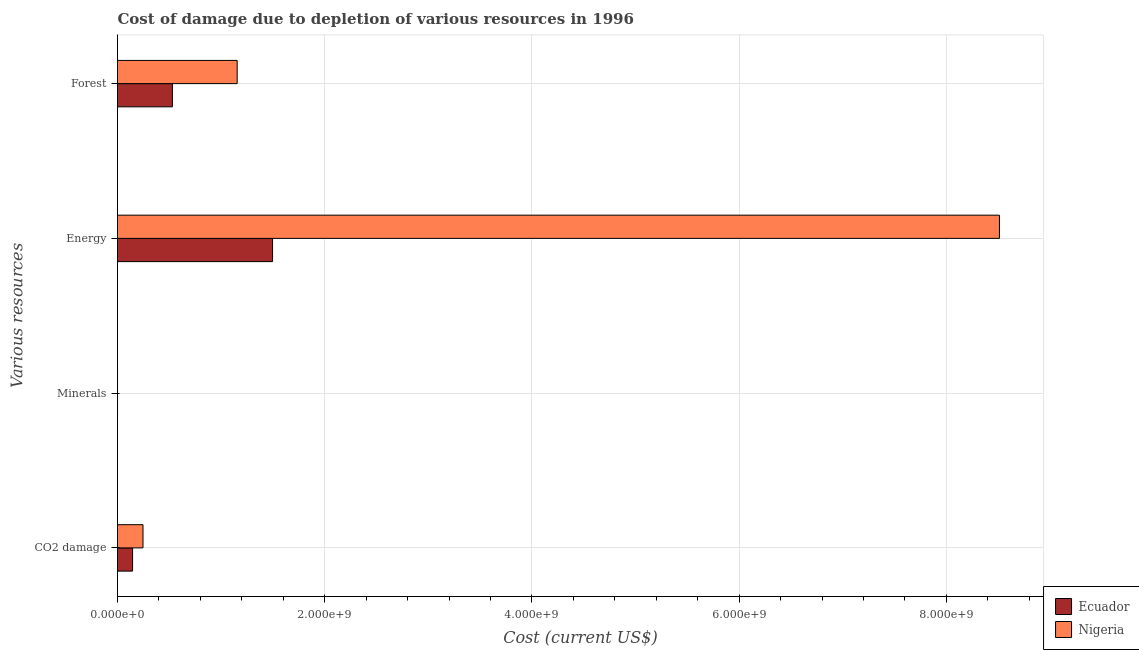Are the number of bars per tick equal to the number of legend labels?
Ensure brevity in your answer.  Yes. Are the number of bars on each tick of the Y-axis equal?
Offer a terse response. Yes. How many bars are there on the 1st tick from the top?
Provide a short and direct response. 2. How many bars are there on the 2nd tick from the bottom?
Offer a very short reply. 2. What is the label of the 1st group of bars from the top?
Offer a very short reply. Forest. What is the cost of damage due to depletion of minerals in Nigeria?
Keep it short and to the point. 1.73e+05. Across all countries, what is the maximum cost of damage due to depletion of minerals?
Ensure brevity in your answer.  1.73e+05. Across all countries, what is the minimum cost of damage due to depletion of energy?
Your response must be concise. 1.50e+09. In which country was the cost of damage due to depletion of coal maximum?
Your answer should be compact. Nigeria. In which country was the cost of damage due to depletion of coal minimum?
Your answer should be compact. Ecuador. What is the total cost of damage due to depletion of energy in the graph?
Your answer should be very brief. 1.00e+1. What is the difference between the cost of damage due to depletion of energy in Nigeria and that in Ecuador?
Make the answer very short. 7.02e+09. What is the difference between the cost of damage due to depletion of minerals in Ecuador and the cost of damage due to depletion of forests in Nigeria?
Provide a succinct answer. -1.15e+09. What is the average cost of damage due to depletion of forests per country?
Your answer should be very brief. 8.42e+08. What is the difference between the cost of damage due to depletion of minerals and cost of damage due to depletion of energy in Ecuador?
Provide a short and direct response. -1.50e+09. What is the ratio of the cost of damage due to depletion of energy in Nigeria to that in Ecuador?
Offer a very short reply. 5.69. Is the cost of damage due to depletion of forests in Nigeria less than that in Ecuador?
Offer a very short reply. No. Is the difference between the cost of damage due to depletion of energy in Nigeria and Ecuador greater than the difference between the cost of damage due to depletion of minerals in Nigeria and Ecuador?
Offer a terse response. Yes. What is the difference between the highest and the second highest cost of damage due to depletion of forests?
Your answer should be compact. 6.25e+08. What is the difference between the highest and the lowest cost of damage due to depletion of forests?
Give a very brief answer. 6.25e+08. In how many countries, is the cost of damage due to depletion of coal greater than the average cost of damage due to depletion of coal taken over all countries?
Offer a terse response. 1. What does the 1st bar from the top in Minerals represents?
Provide a succinct answer. Nigeria. What does the 1st bar from the bottom in Forest represents?
Your response must be concise. Ecuador. How many bars are there?
Offer a very short reply. 8. Does the graph contain any zero values?
Your answer should be compact. No. Does the graph contain grids?
Ensure brevity in your answer.  Yes. How many legend labels are there?
Give a very brief answer. 2. How are the legend labels stacked?
Provide a short and direct response. Vertical. What is the title of the graph?
Offer a very short reply. Cost of damage due to depletion of various resources in 1996 . What is the label or title of the X-axis?
Your response must be concise. Cost (current US$). What is the label or title of the Y-axis?
Offer a very short reply. Various resources. What is the Cost (current US$) of Ecuador in CO2 damage?
Offer a terse response. 1.45e+08. What is the Cost (current US$) in Nigeria in CO2 damage?
Provide a short and direct response. 2.46e+08. What is the Cost (current US$) of Ecuador in Minerals?
Give a very brief answer. 5.43e+04. What is the Cost (current US$) in Nigeria in Minerals?
Your answer should be very brief. 1.73e+05. What is the Cost (current US$) in Ecuador in Energy?
Your response must be concise. 1.50e+09. What is the Cost (current US$) in Nigeria in Energy?
Give a very brief answer. 8.51e+09. What is the Cost (current US$) in Ecuador in Forest?
Provide a succinct answer. 5.30e+08. What is the Cost (current US$) in Nigeria in Forest?
Your response must be concise. 1.16e+09. Across all Various resources, what is the maximum Cost (current US$) of Ecuador?
Make the answer very short. 1.50e+09. Across all Various resources, what is the maximum Cost (current US$) of Nigeria?
Provide a short and direct response. 8.51e+09. Across all Various resources, what is the minimum Cost (current US$) of Ecuador?
Offer a terse response. 5.43e+04. Across all Various resources, what is the minimum Cost (current US$) in Nigeria?
Your answer should be very brief. 1.73e+05. What is the total Cost (current US$) of Ecuador in the graph?
Give a very brief answer. 2.17e+09. What is the total Cost (current US$) in Nigeria in the graph?
Make the answer very short. 9.91e+09. What is the difference between the Cost (current US$) in Ecuador in CO2 damage and that in Minerals?
Give a very brief answer. 1.45e+08. What is the difference between the Cost (current US$) in Nigeria in CO2 damage and that in Minerals?
Offer a terse response. 2.46e+08. What is the difference between the Cost (current US$) of Ecuador in CO2 damage and that in Energy?
Offer a terse response. -1.35e+09. What is the difference between the Cost (current US$) in Nigeria in CO2 damage and that in Energy?
Offer a terse response. -8.27e+09. What is the difference between the Cost (current US$) in Ecuador in CO2 damage and that in Forest?
Your answer should be very brief. -3.84e+08. What is the difference between the Cost (current US$) of Nigeria in CO2 damage and that in Forest?
Keep it short and to the point. -9.09e+08. What is the difference between the Cost (current US$) of Ecuador in Minerals and that in Energy?
Your answer should be compact. -1.50e+09. What is the difference between the Cost (current US$) in Nigeria in Minerals and that in Energy?
Give a very brief answer. -8.51e+09. What is the difference between the Cost (current US$) of Ecuador in Minerals and that in Forest?
Your response must be concise. -5.30e+08. What is the difference between the Cost (current US$) of Nigeria in Minerals and that in Forest?
Offer a terse response. -1.15e+09. What is the difference between the Cost (current US$) of Ecuador in Energy and that in Forest?
Keep it short and to the point. 9.67e+08. What is the difference between the Cost (current US$) of Nigeria in Energy and that in Forest?
Keep it short and to the point. 7.36e+09. What is the difference between the Cost (current US$) of Ecuador in CO2 damage and the Cost (current US$) of Nigeria in Minerals?
Keep it short and to the point. 1.45e+08. What is the difference between the Cost (current US$) of Ecuador in CO2 damage and the Cost (current US$) of Nigeria in Energy?
Give a very brief answer. -8.37e+09. What is the difference between the Cost (current US$) in Ecuador in CO2 damage and the Cost (current US$) in Nigeria in Forest?
Your response must be concise. -1.01e+09. What is the difference between the Cost (current US$) in Ecuador in Minerals and the Cost (current US$) in Nigeria in Energy?
Provide a succinct answer. -8.51e+09. What is the difference between the Cost (current US$) in Ecuador in Minerals and the Cost (current US$) in Nigeria in Forest?
Your answer should be very brief. -1.15e+09. What is the difference between the Cost (current US$) of Ecuador in Energy and the Cost (current US$) of Nigeria in Forest?
Provide a succinct answer. 3.42e+08. What is the average Cost (current US$) in Ecuador per Various resources?
Offer a very short reply. 5.43e+08. What is the average Cost (current US$) of Nigeria per Various resources?
Offer a very short reply. 2.48e+09. What is the difference between the Cost (current US$) of Ecuador and Cost (current US$) of Nigeria in CO2 damage?
Offer a terse response. -1.01e+08. What is the difference between the Cost (current US$) in Ecuador and Cost (current US$) in Nigeria in Minerals?
Ensure brevity in your answer.  -1.19e+05. What is the difference between the Cost (current US$) in Ecuador and Cost (current US$) in Nigeria in Energy?
Provide a succinct answer. -7.02e+09. What is the difference between the Cost (current US$) of Ecuador and Cost (current US$) of Nigeria in Forest?
Provide a succinct answer. -6.25e+08. What is the ratio of the Cost (current US$) in Ecuador in CO2 damage to that in Minerals?
Make the answer very short. 2677.21. What is the ratio of the Cost (current US$) in Nigeria in CO2 damage to that in Minerals?
Ensure brevity in your answer.  1423.72. What is the ratio of the Cost (current US$) of Ecuador in CO2 damage to that in Energy?
Offer a very short reply. 0.1. What is the ratio of the Cost (current US$) of Nigeria in CO2 damage to that in Energy?
Provide a succinct answer. 0.03. What is the ratio of the Cost (current US$) in Ecuador in CO2 damage to that in Forest?
Give a very brief answer. 0.27. What is the ratio of the Cost (current US$) in Nigeria in CO2 damage to that in Forest?
Give a very brief answer. 0.21. What is the ratio of the Cost (current US$) of Ecuador in Minerals to that in Energy?
Your answer should be very brief. 0. What is the ratio of the Cost (current US$) in Nigeria in Minerals to that in Forest?
Ensure brevity in your answer.  0. What is the ratio of the Cost (current US$) of Ecuador in Energy to that in Forest?
Provide a short and direct response. 2.83. What is the ratio of the Cost (current US$) in Nigeria in Energy to that in Forest?
Provide a short and direct response. 7.37. What is the difference between the highest and the second highest Cost (current US$) of Ecuador?
Your answer should be very brief. 9.67e+08. What is the difference between the highest and the second highest Cost (current US$) in Nigeria?
Keep it short and to the point. 7.36e+09. What is the difference between the highest and the lowest Cost (current US$) in Ecuador?
Provide a short and direct response. 1.50e+09. What is the difference between the highest and the lowest Cost (current US$) of Nigeria?
Give a very brief answer. 8.51e+09. 